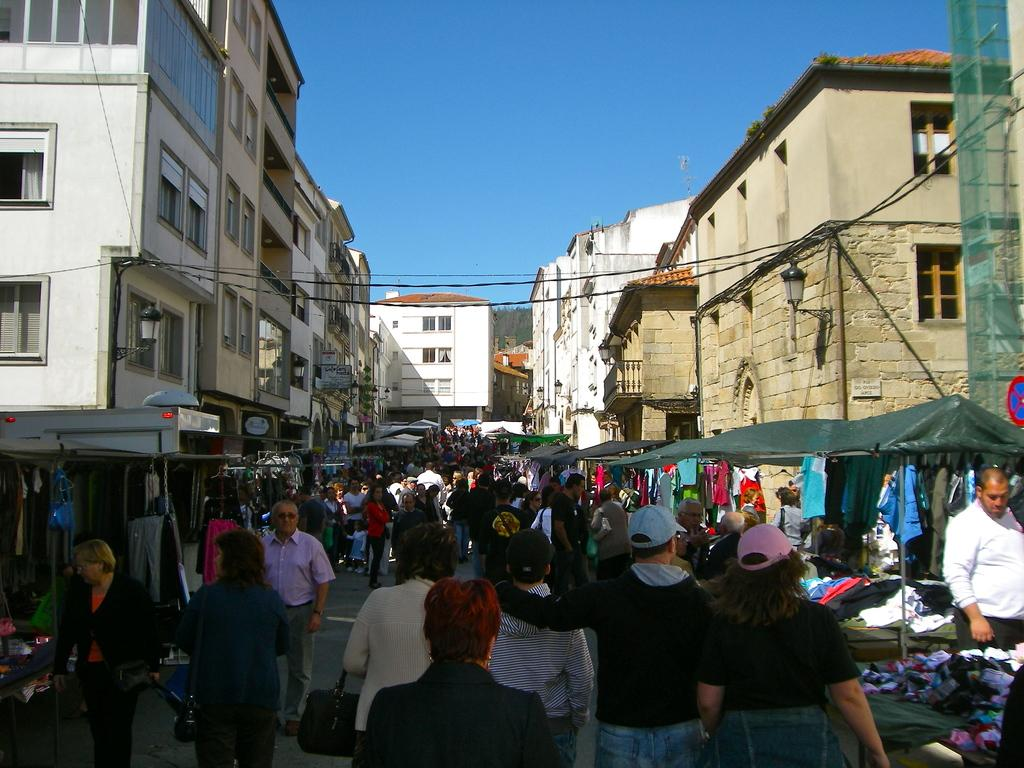How many people are in the image? There is a group of people in the image, but the exact number is not specified. What are the people in the image doing? The people in the image are walking on the ground. What can be seen in the background of the image? There are buildings, the sky, stalls, clothes, and other objects visible in the background of the image. What type of drain is visible in the image? There is no drain present in the image. What kind of pets are accompanying the people in the image? There are no pets visible in the image. 